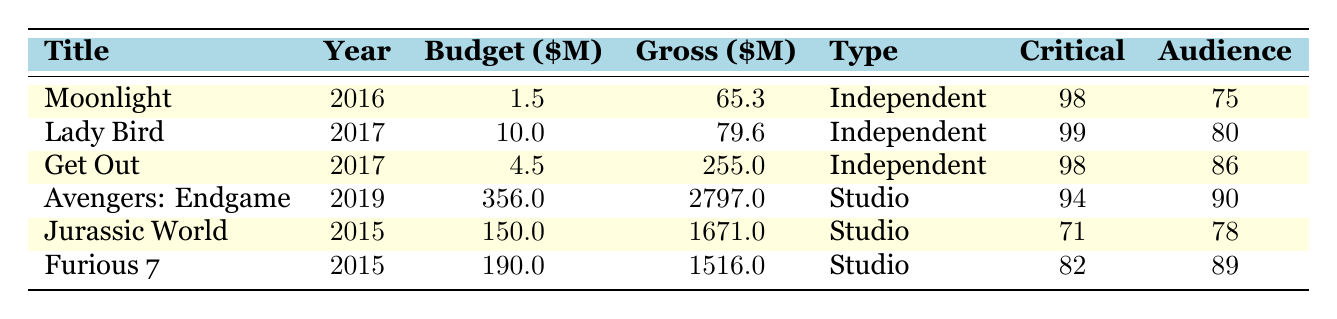What is the highest worldwide gross of an independent film in the table? The highest worldwide gross for an independent film can be found by looking at the "Gross" column for independent films. The values are 65.3 (Moonlight), 79.6 (Lady Bird), and 255.0 (Get Out). The highest value among these is 255.0 for Get Out.
Answer: 255.0 Which independent film has the lowest critical rating? In the table, the critical ratings for independent films are 98 (Moonlight), 99 (Lady Bird), and 98 (Get Out). The lowest value among these is 98, which belongs to both Moonlight and Get Out.
Answer: Moonlight and Get Out How much total budget was spent on the studio films? The total budget for studio films can be calculated by summing the "Budget" column for those films: 356 (Avengers: Endgame) + 150 (Jurassic World) + 190 (Furious 7). This gives us a total of 696.
Answer: 696 Is the audience rating for "Get Out" higher than that of "Avengers: Endgame"? The table shows the audience rating for Get Out is 86 and for Avengers: Endgame is 90. Since 86 is less than 90, the statement is false.
Answer: No What is the average worldwide gross of the independent films listed? To find the average worldwide gross of independent films, we add their gross values: 65.3 (Moonlight) + 79.6 (Lady Bird) + 255.0 (Get Out) = 399.9. There are 3 independent films, so we divide 399.9 by 3, which gives 133.3.
Answer: 133.3 Which film type has a greater average critical rating: independent or studio? The average critical ratings must be calculated for both types. For independent films, the ratings are 98 (Moonlight), 99 (Lady Bird), and 98 (Get Out), giving an average of (98 + 99 + 98) / 3 = 98.67. For studio films: 94 (Avengers: Endgame), 71 (Jurassic World), and 82 (Furious 7), which averages to (94 + 71 + 82) / 3 = 82.33. Since 98.67 is greater than 82.33, independent films have a higher average critical rating.
Answer: Independent films Did any of the studio films gross over 2000 million dollars? Examining the "Gross" column for studio films, we see their values are 2797 (Avengers: Endgame), 1671 (Jurassic World), and 1516 (Furious 7). Since 2797 million exceeds 2000 million, the answer is yes.
Answer: Yes What is the difference in audience ratings between the highest-rated independent film and the highest-rated studio film? The highest audience rating for an independent film is 86 (Get Out), and for studio films, it is 90 (Avengers: Endgame). The difference is calculated as 90 - 86 = 4.
Answer: 4 